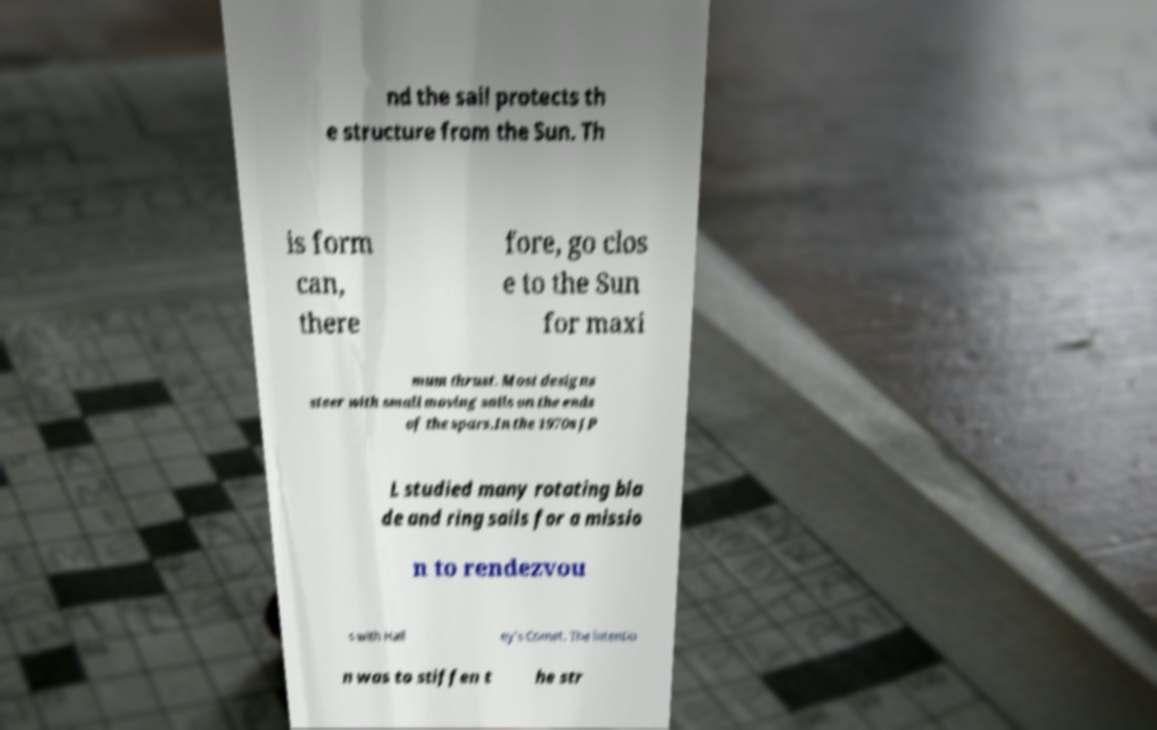Can you read and provide the text displayed in the image?This photo seems to have some interesting text. Can you extract and type it out for me? nd the sail protects th e structure from the Sun. Th is form can, there fore, go clos e to the Sun for maxi mum thrust. Most designs steer with small moving sails on the ends of the spars.In the 1970s JP L studied many rotating bla de and ring sails for a missio n to rendezvou s with Hall ey's Comet. The intentio n was to stiffen t he str 